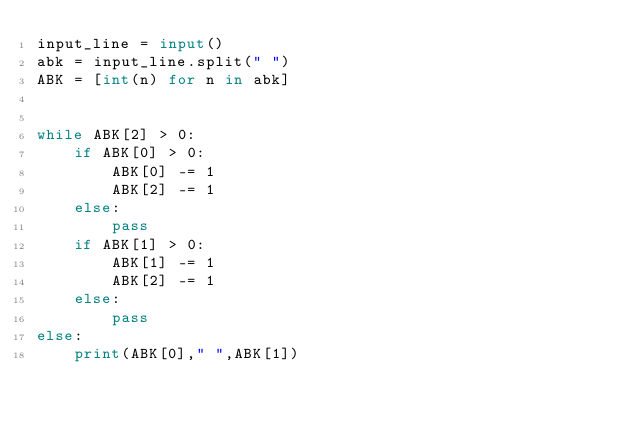Convert code to text. <code><loc_0><loc_0><loc_500><loc_500><_Python_>input_line = input()
abk = input_line.split(" ") 
ABK = [int(n) for n in abk]


while ABK[2] > 0:
    if ABK[0] > 0:
        ABK[0] -= 1
        ABK[2] -= 1
    else:
        pass
    if ABK[1] > 0: 
        ABK[1] -= 1
        ABK[2] -= 1
    else:
        pass
else:
    print(ABK[0]," ",ABK[1])



</code> 